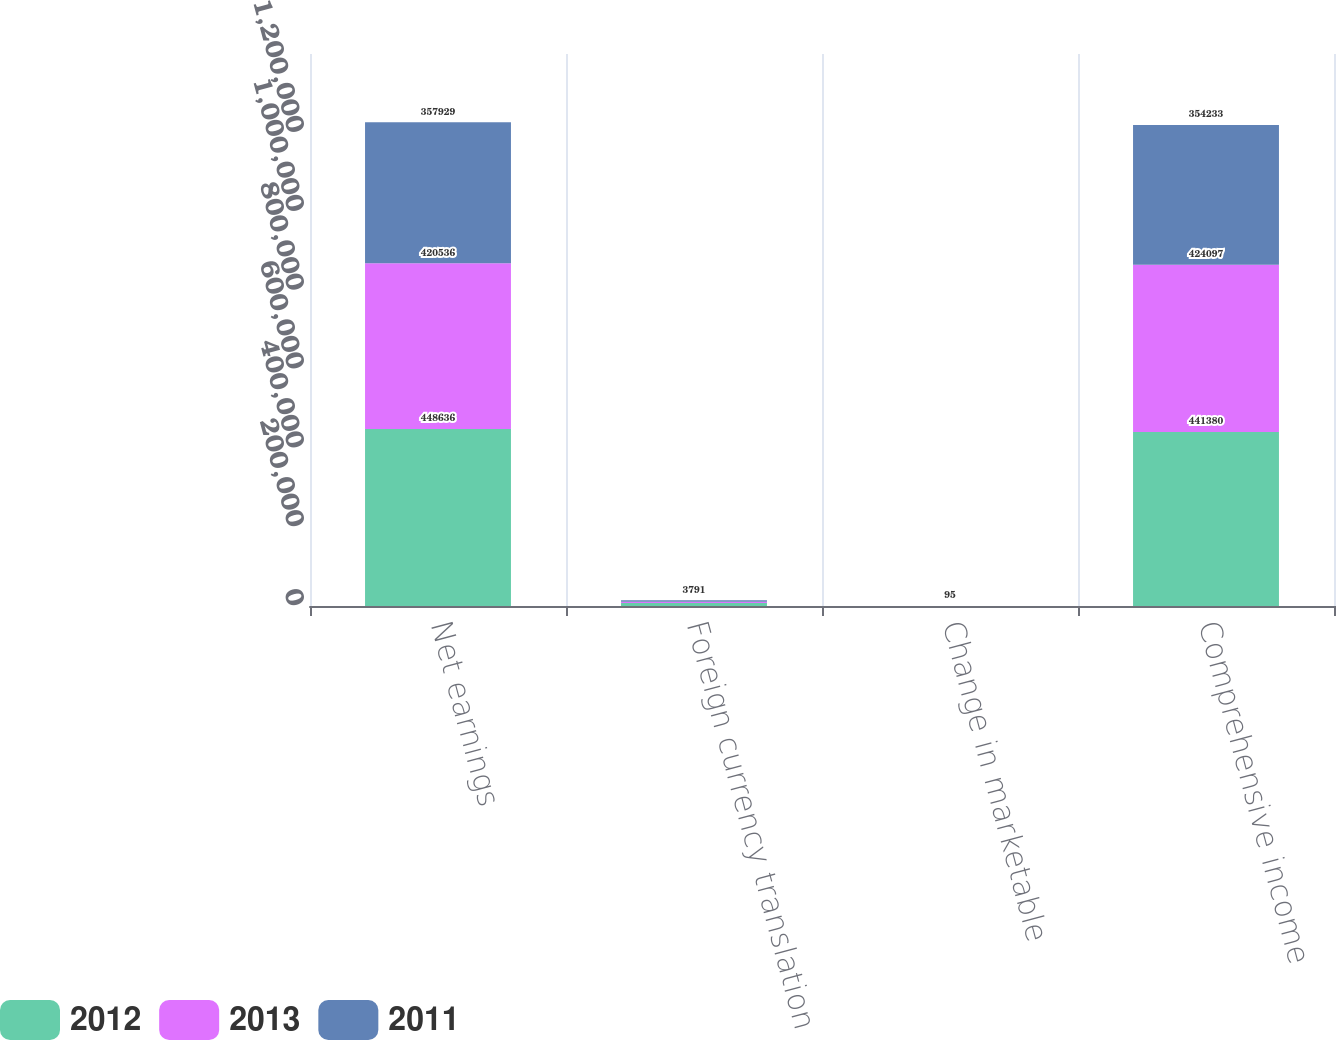Convert chart to OTSL. <chart><loc_0><loc_0><loc_500><loc_500><stacked_bar_chart><ecel><fcel>Net earnings<fcel>Foreign currency translation<fcel>Change in marketable<fcel>Comprehensive income<nl><fcel>2012<fcel>448636<fcel>7354<fcel>98<fcel>441380<nl><fcel>2013<fcel>420536<fcel>3522<fcel>39<fcel>424097<nl><fcel>2011<fcel>357929<fcel>3791<fcel>95<fcel>354233<nl></chart> 